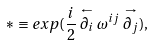Convert formula to latex. <formula><loc_0><loc_0><loc_500><loc_500>* \equiv e x p ( \frac { i } { 2 } \stackrel { \leftarrow } { \partial _ { i } } \omega ^ { i j } \stackrel { \rightarrow } { \partial _ { j } } ) ,</formula> 